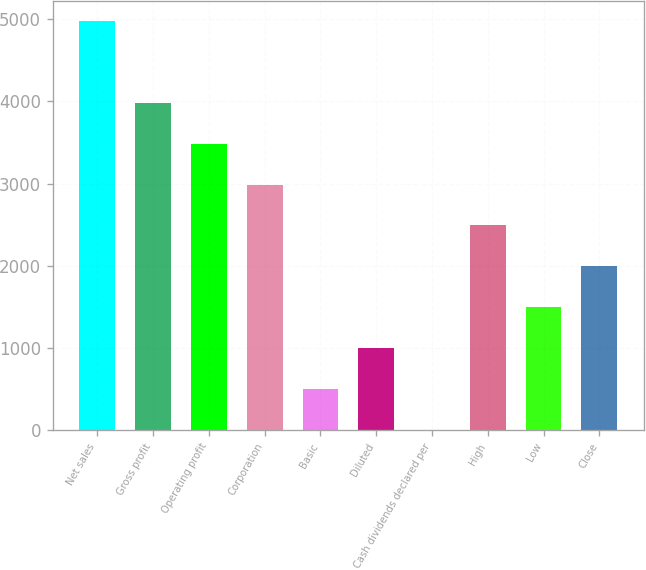Convert chart. <chart><loc_0><loc_0><loc_500><loc_500><bar_chart><fcel>Net sales<fcel>Gross profit<fcel>Operating profit<fcel>Corporation<fcel>Basic<fcel>Diluted<fcel>Cash dividends declared per<fcel>High<fcel>Low<fcel>Close<nl><fcel>4979<fcel>3983.3<fcel>3485.47<fcel>2987.64<fcel>498.49<fcel>996.32<fcel>0.66<fcel>2489.81<fcel>1494.15<fcel>1991.98<nl></chart> 